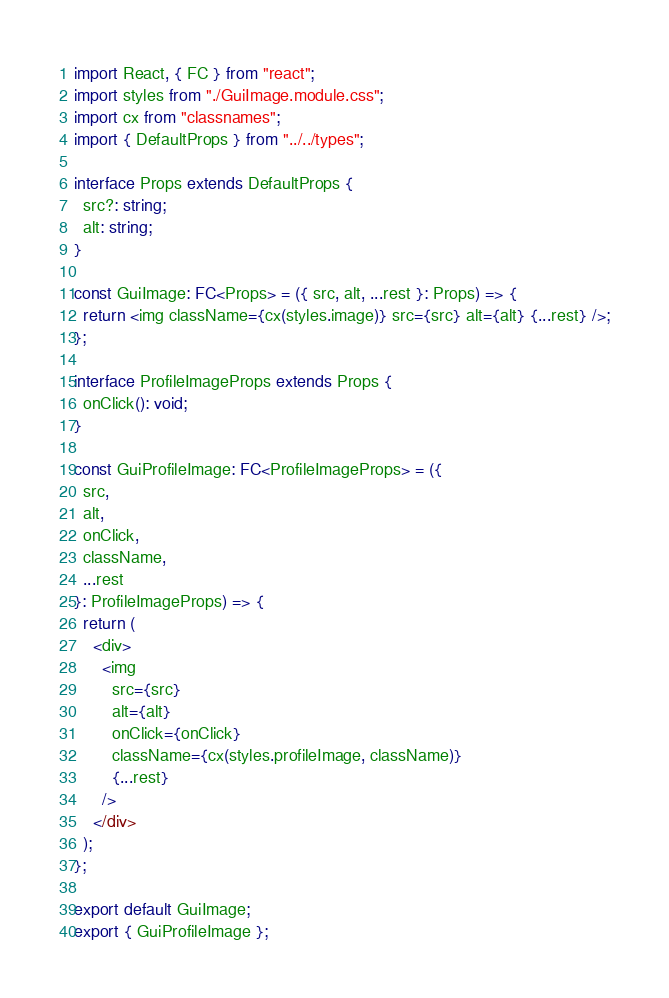<code> <loc_0><loc_0><loc_500><loc_500><_TypeScript_>import React, { FC } from "react";
import styles from "./GuiImage.module.css";
import cx from "classnames";
import { DefaultProps } from "../../types";

interface Props extends DefaultProps {
  src?: string;
  alt: string;
}

const GuiImage: FC<Props> = ({ src, alt, ...rest }: Props) => {
  return <img className={cx(styles.image)} src={src} alt={alt} {...rest} />;
};

interface ProfileImageProps extends Props {
  onClick(): void;
}

const GuiProfileImage: FC<ProfileImageProps> = ({
  src,
  alt,
  onClick,
  className,
  ...rest
}: ProfileImageProps) => {
  return (
    <div>
      <img
        src={src}
        alt={alt}
        onClick={onClick}
        className={cx(styles.profileImage, className)}
        {...rest}
      />
    </div>
  );
};

export default GuiImage;
export { GuiProfileImage };
</code> 